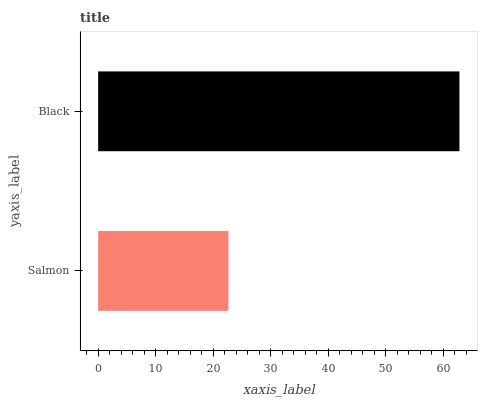Is Salmon the minimum?
Answer yes or no. Yes. Is Black the maximum?
Answer yes or no. Yes. Is Black the minimum?
Answer yes or no. No. Is Black greater than Salmon?
Answer yes or no. Yes. Is Salmon less than Black?
Answer yes or no. Yes. Is Salmon greater than Black?
Answer yes or no. No. Is Black less than Salmon?
Answer yes or no. No. Is Black the high median?
Answer yes or no. Yes. Is Salmon the low median?
Answer yes or no. Yes. Is Salmon the high median?
Answer yes or no. No. Is Black the low median?
Answer yes or no. No. 